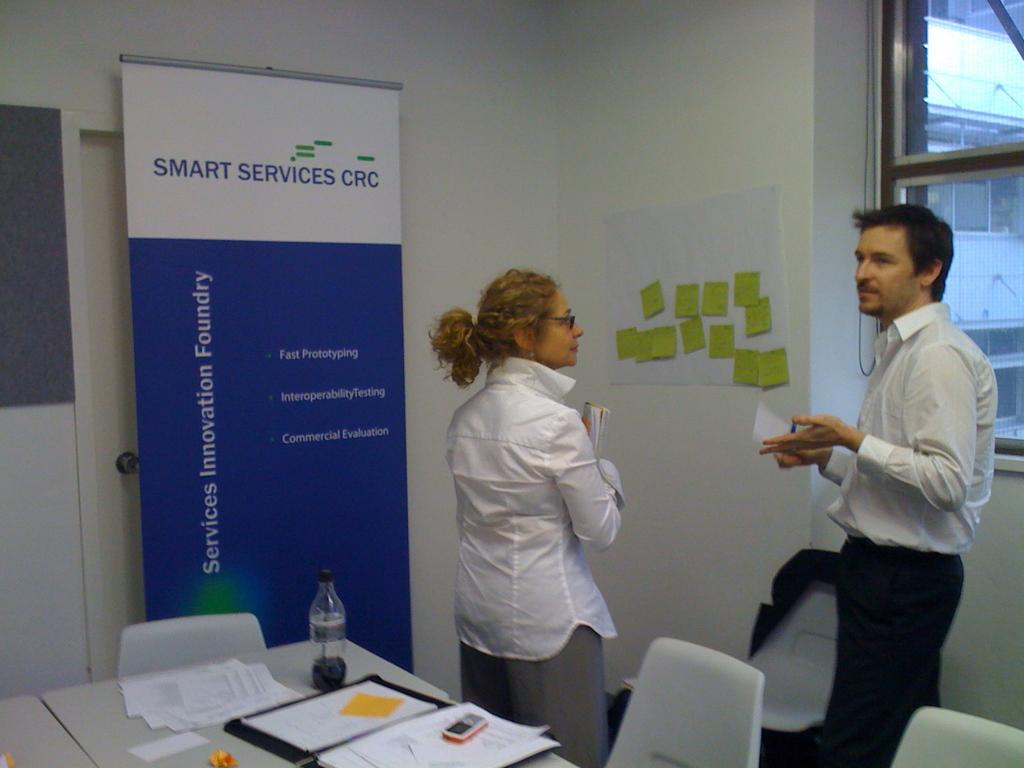<image>
Provide a brief description of the given image. a sign next to people called smart services crc 